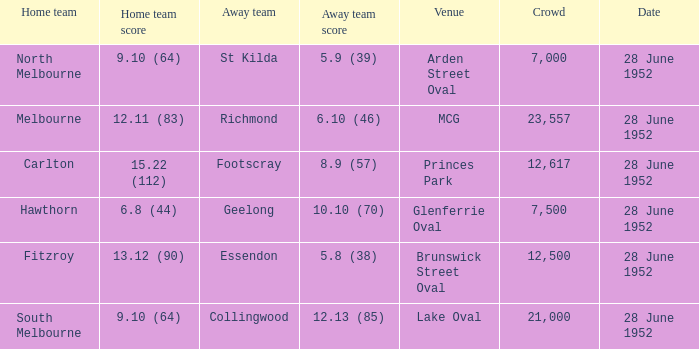Which team is considered the guests when north melbourne is at home? St Kilda. 